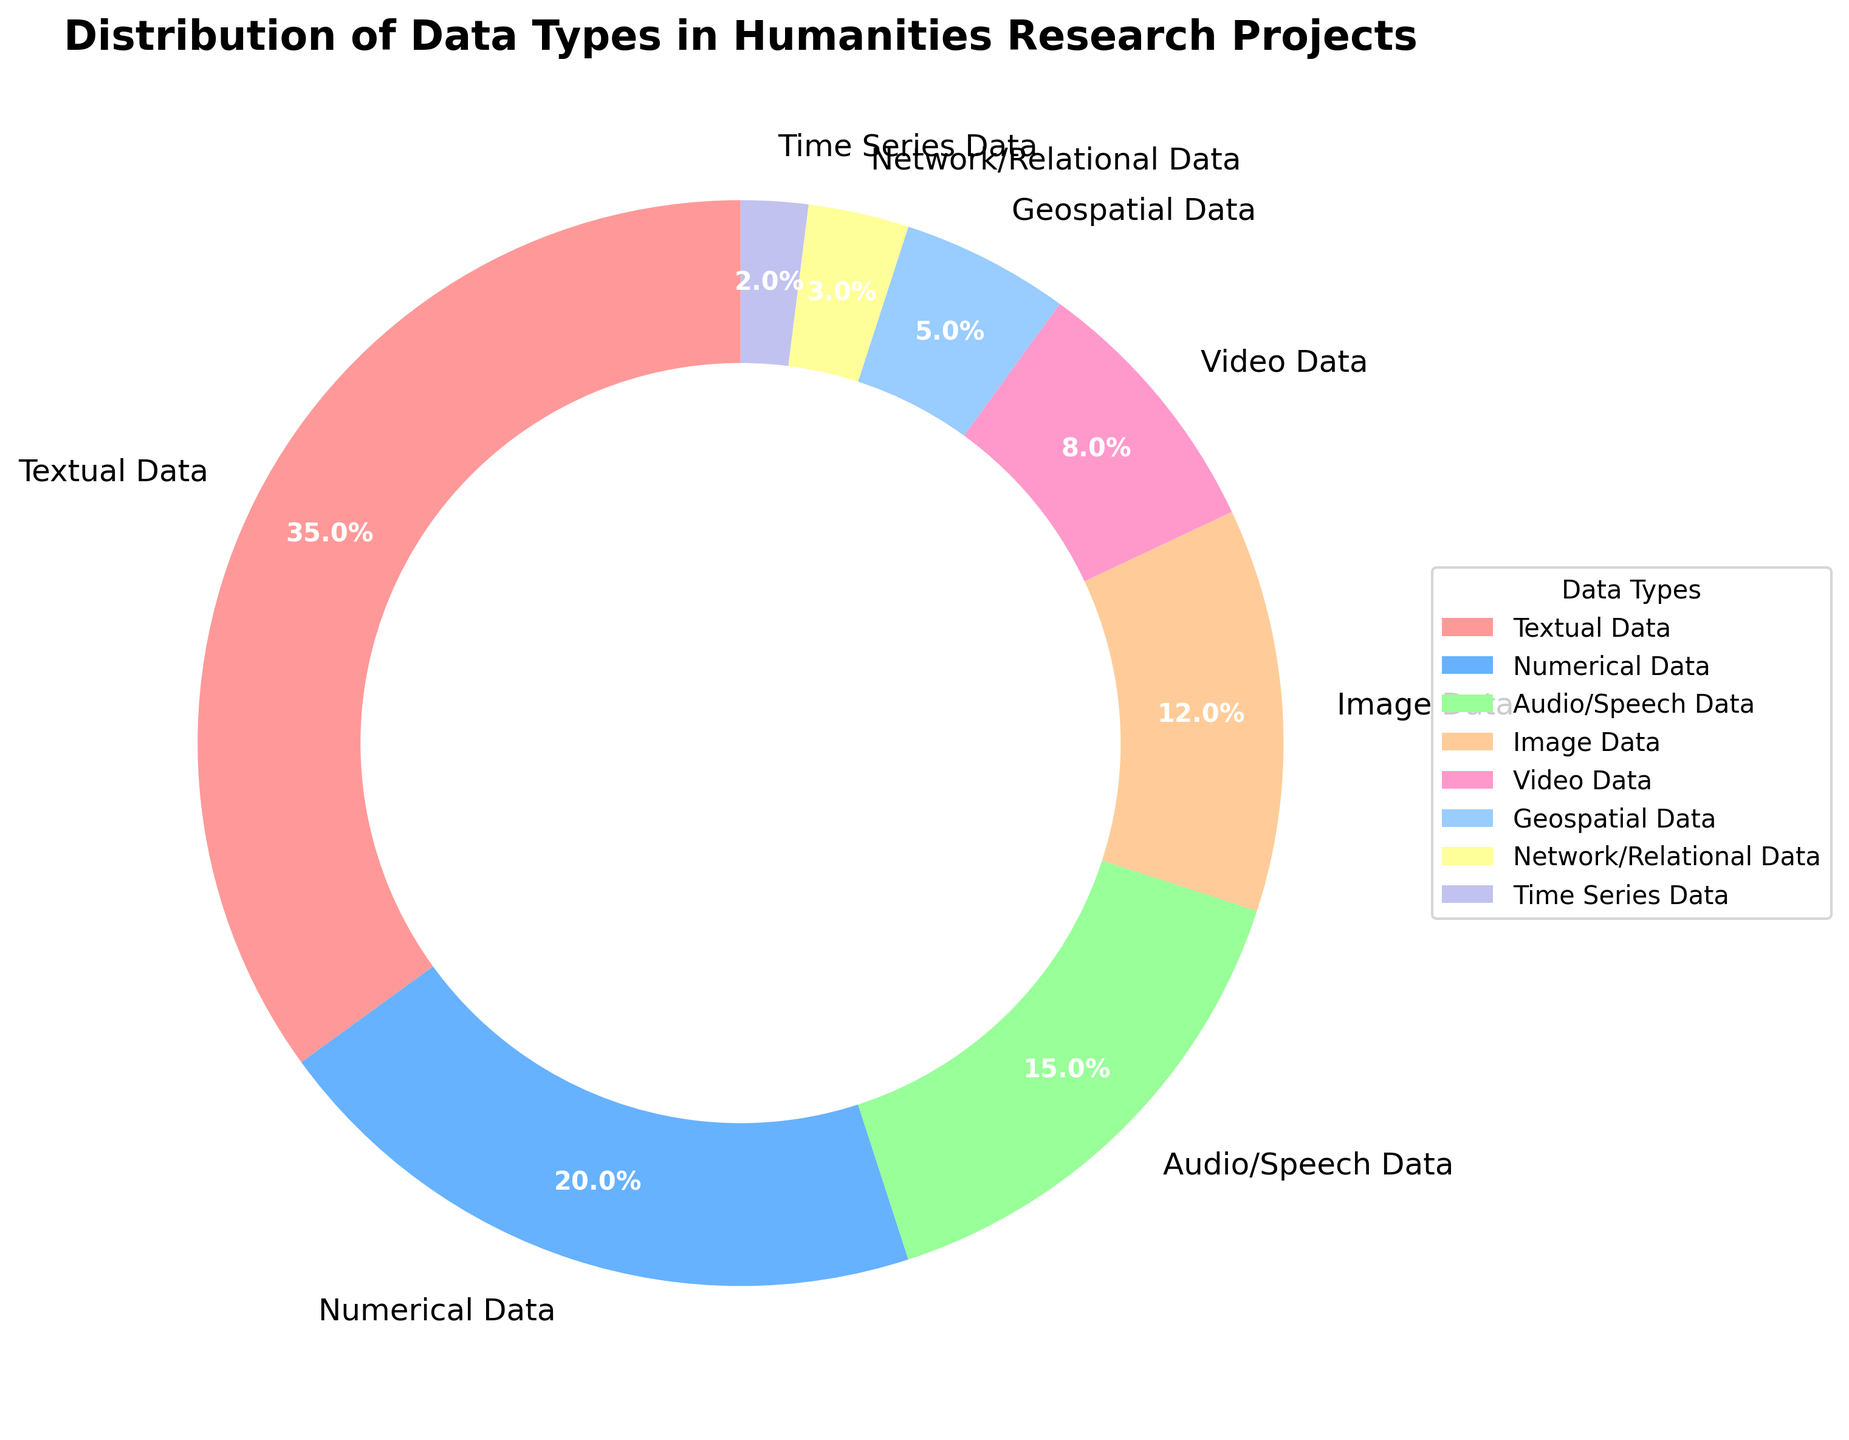What percentage of the data types used in humanities research projects is textual data? The percentage of textual data can be directly read from the figure. It is represented by one segment of the pie chart labeled as "Textual Data."
Answer: 35% Which data type has the second highest percentage? To determine the second highest percentage, compare the size of each pie segment and identify the one following the largest (Textual Data). According to the figure, Numerical Data is the second largest segment.
Answer: Numerical Data How much larger is the percentage of textual data compared to image data? Subtract the percentage of image data from the percentage of textual data: 35% (Textual Data) - 12% (Image Data) = 23%.
Answer: 23% What are the combined percentages of video, geospatial, network/relational, and time series data? Add the percentages of these four data types: 8% (Video Data) + 5% (Geospatial Data) + 3% (Network/Relational Data) + 2% (Time Series Data) = 18%.
Answer: 18% What data type is represented by the light pink color in the pie chart? The visual attribute, light pink color, represents one segment of the pie chart. By identifying the segment with this color, we can infer that it is associated with Textual Data.
Answer: Textual Data Which data type has the smallest percentage? By observing the size of each pie segment, the smallest segment can be identified, which is Time Series Data.
Answer: Time Series Data Which is greater, the percentage of audio/speech data or video data? Compare the percentages of audio/speech data (15%) and video data (8%). Since 15% is greater than 8%, audio/speech data has a larger percentage.
Answer: Audio/Speech Data How much more prevalent is network/relational data compared to time series data? Subtract the percentage of time series data from the percentage of network/relational data: 3% (Network/Relational Data) - 2% (Time Series Data) = 1%.
Answer: 1% What is the total percentage of textual, numerical, and audio/speech data combined? Add the percentages of these three data types: 35% (Textual Data) + 20% (Numerical Data) + 15% (Audio/Speech Data) = 70%.
Answer: 70% 